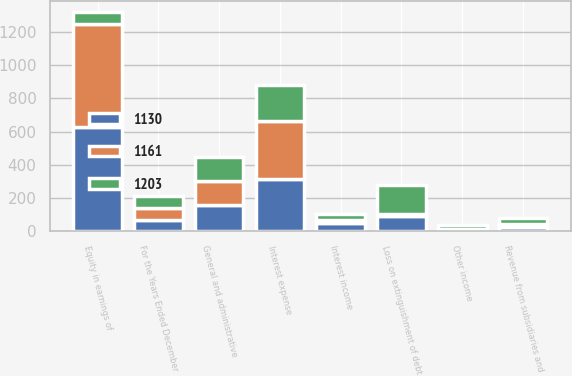<chart> <loc_0><loc_0><loc_500><loc_500><stacked_bar_chart><ecel><fcel>For the Years Ended December<fcel>Revenue from subsidiaries and<fcel>Equity in earnings of<fcel>Interest income<fcel>General and administrative<fcel>Other income<fcel>Loss on extinguishment of debt<fcel>Interest expense<nl><fcel>1203<fcel>70.5<fcel>36<fcel>70.5<fcel>39<fcel>142<fcel>25<fcel>171<fcel>220<nl><fcel>1130<fcel>70.5<fcel>28<fcel>630<fcel>49<fcel>158<fcel>5<fcel>92<fcel>317<nl><fcel>1161<fcel>70.5<fcel>14<fcel>615<fcel>19<fcel>144<fcel>7<fcel>14<fcel>344<nl></chart> 